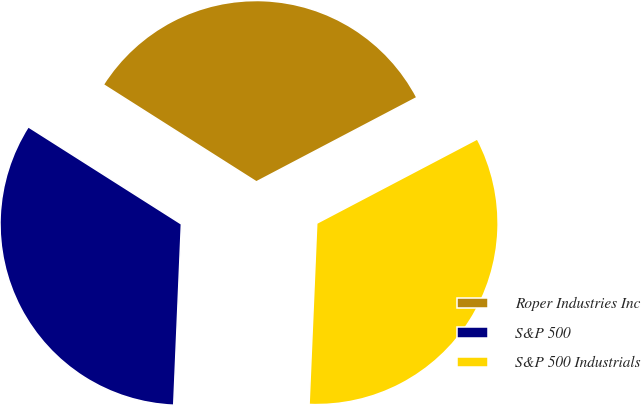Convert chart. <chart><loc_0><loc_0><loc_500><loc_500><pie_chart><fcel>Roper Industries Inc<fcel>S&P 500<fcel>S&P 500 Industrials<nl><fcel>33.3%<fcel>33.33%<fcel>33.37%<nl></chart> 